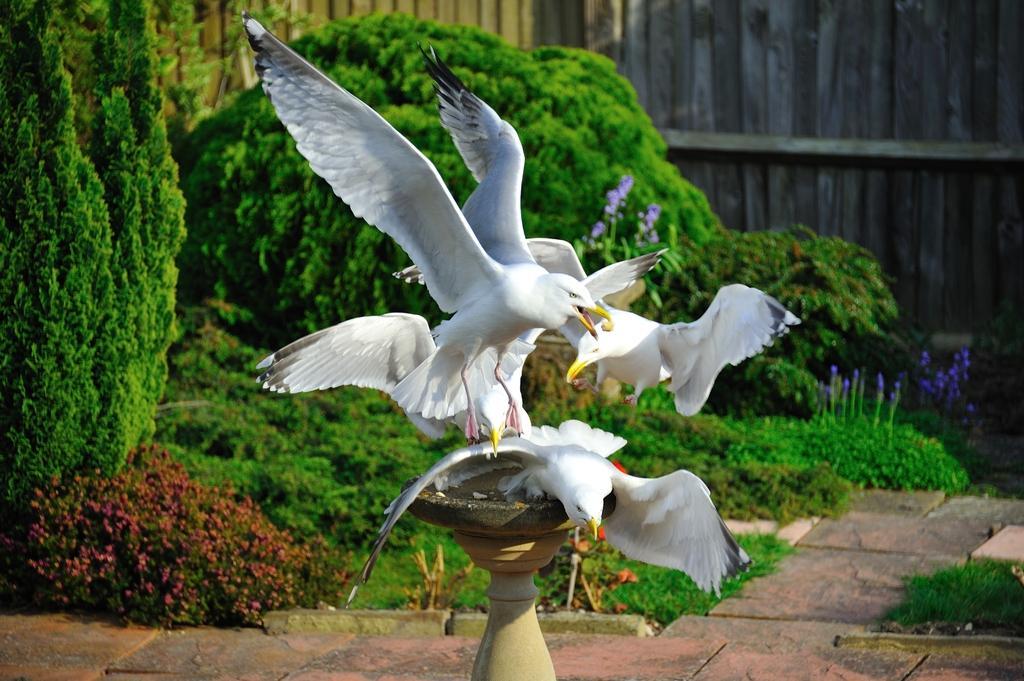Can you describe this image briefly? In the center of the image there are birds. At the bottom there is a pedestal. In the background there are bushes and a fence. 